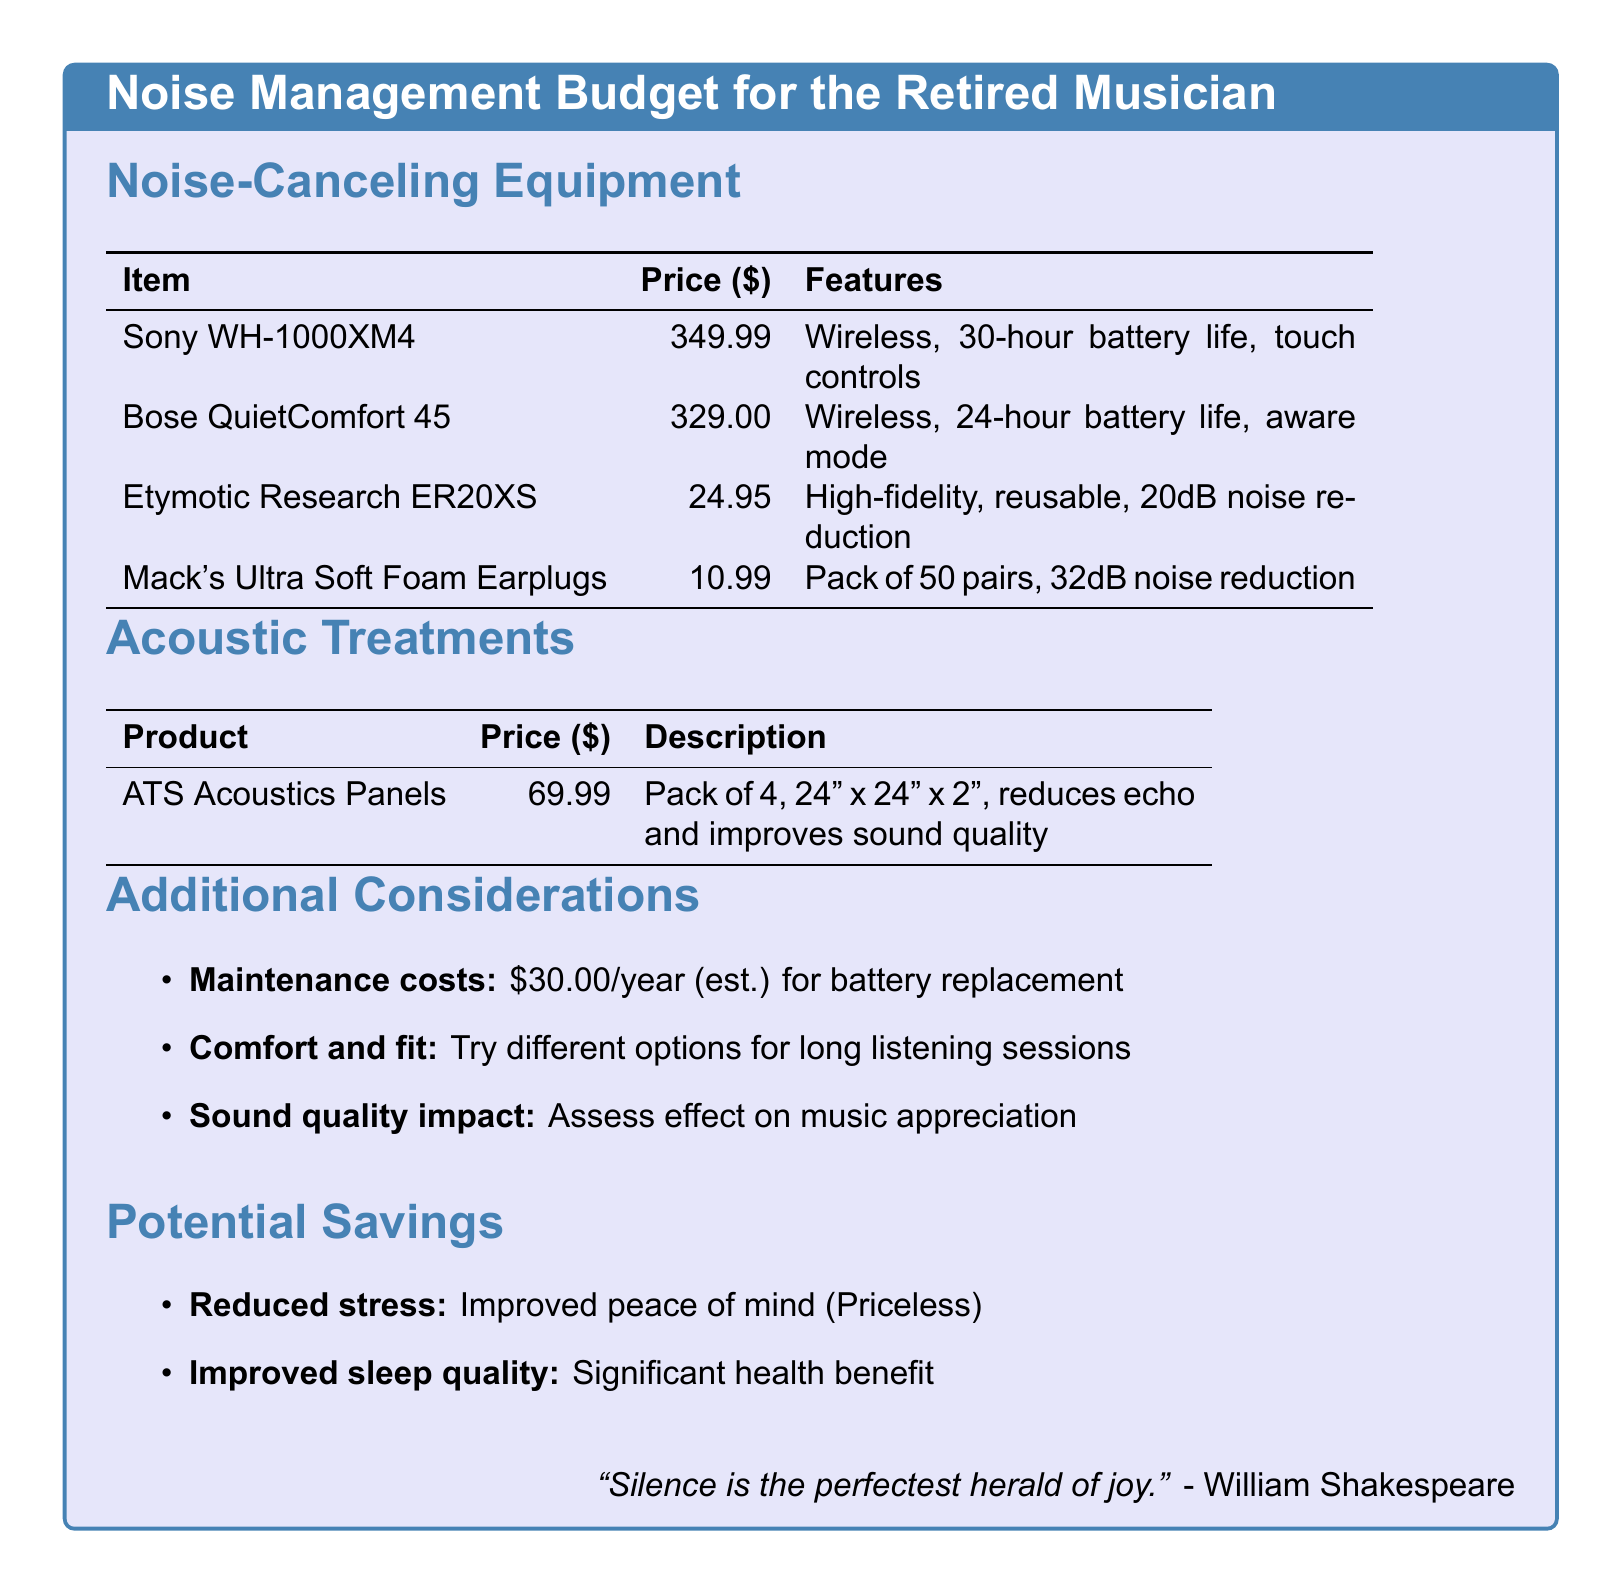What is the price of Sony WH-1000XM4? The price is mentioned in the Noise-Canceling Equipment section for the Sony WH-1000XM4, which is $349.99.
Answer: $349.99 How many pairs of Mack's Ultra Soft Foam Earplugs are included in a pack? The document states that the Mack's Ultra Soft Foam Earplugs come in a pack of 50 pairs.
Answer: 50 pairs What is the noise reduction level of Etymotic Research ER20XS? The document indicates that Etymotic Research ER20XS provides a noise reduction of 20dB.
Answer: 20dB What is the estimated maintenance cost per year for the headphones? The document outlines that the estimated maintenance costs for battery replacement are $30.00 per year.
Answer: $30.00 What type of acoustic treatment is mentioned? The document lists ATS Acoustics Panels as the type of acoustic treatment provided.
Answer: ATS Acoustics Panels What is the impact of improved sleep quality classified as in potential savings? The document states that improved sleep quality is considered a significant health benefit under potential savings.
Answer: Significant health benefit How many hours of battery life does Bose QuietComfort 45 have? The document indicates that the Bose QuietComfort 45 has a battery life of 24 hours.
Answer: 24 hours What is the material of ATS Acoustics Panels? The document does not explicitly state the material, focusing instead on the purpose and dimensions; it mentions reducing echo and improving sound quality.
Answer: Not mentioned What is the purpose of the maintenance cost listed in the document? The maintenance cost in the document is for battery replacement for the headphones.
Answer: Battery replacement 